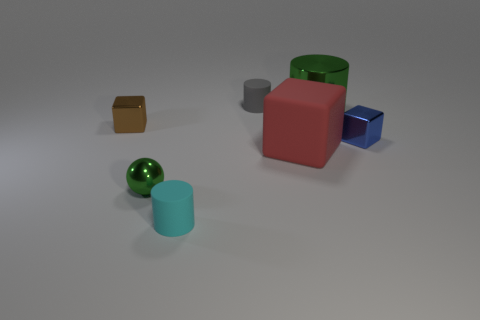Add 2 green things. How many objects exist? 9 Subtract all blue shiny cubes. How many cubes are left? 2 Subtract all blocks. How many objects are left? 4 Subtract all yellow blocks. Subtract all green cylinders. How many blocks are left? 3 Subtract all big green shiny things. Subtract all big red cubes. How many objects are left? 5 Add 1 blue shiny objects. How many blue shiny objects are left? 2 Add 1 tiny blue objects. How many tiny blue objects exist? 2 Subtract 0 green blocks. How many objects are left? 7 